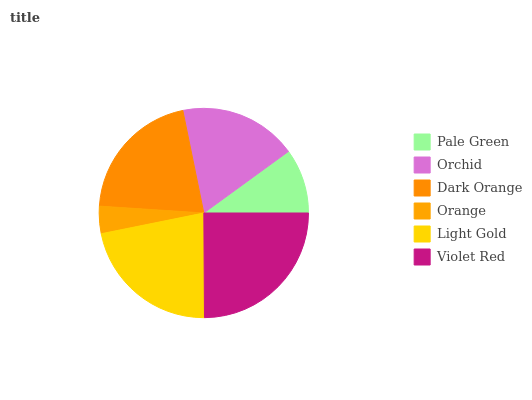Is Orange the minimum?
Answer yes or no. Yes. Is Violet Red the maximum?
Answer yes or no. Yes. Is Orchid the minimum?
Answer yes or no. No. Is Orchid the maximum?
Answer yes or no. No. Is Orchid greater than Pale Green?
Answer yes or no. Yes. Is Pale Green less than Orchid?
Answer yes or no. Yes. Is Pale Green greater than Orchid?
Answer yes or no. No. Is Orchid less than Pale Green?
Answer yes or no. No. Is Dark Orange the high median?
Answer yes or no. Yes. Is Orchid the low median?
Answer yes or no. Yes. Is Light Gold the high median?
Answer yes or no. No. Is Violet Red the low median?
Answer yes or no. No. 